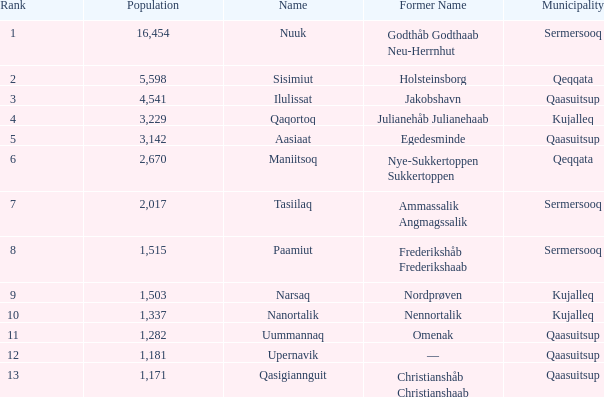Who was once called nordprøven? Narsaq. 